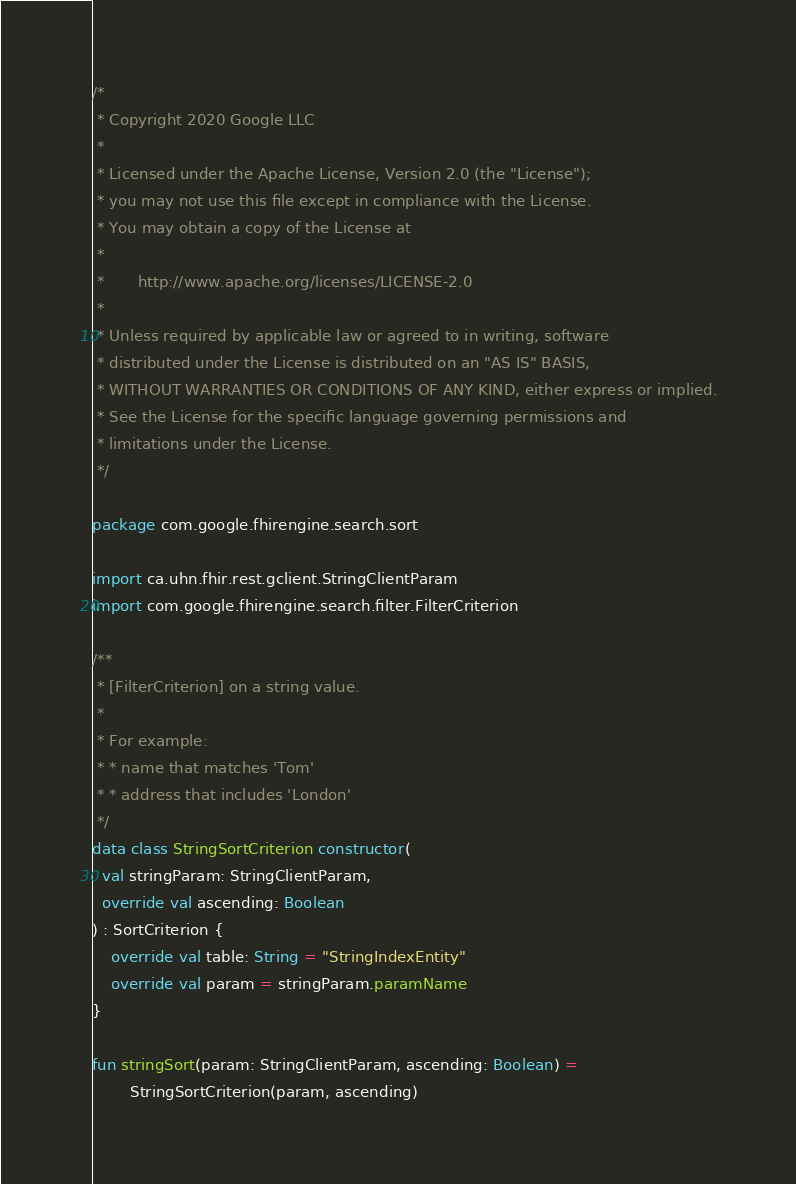<code> <loc_0><loc_0><loc_500><loc_500><_Kotlin_>/*
 * Copyright 2020 Google LLC
 *
 * Licensed under the Apache License, Version 2.0 (the "License");
 * you may not use this file except in compliance with the License.
 * You may obtain a copy of the License at
 *
 *       http://www.apache.org/licenses/LICENSE-2.0
 *
 * Unless required by applicable law or agreed to in writing, software
 * distributed under the License is distributed on an "AS IS" BASIS,
 * WITHOUT WARRANTIES OR CONDITIONS OF ANY KIND, either express or implied.
 * See the License for the specific language governing permissions and
 * limitations under the License.
 */

package com.google.fhirengine.search.sort

import ca.uhn.fhir.rest.gclient.StringClientParam
import com.google.fhirengine.search.filter.FilterCriterion

/**
 * [FilterCriterion] on a string value.
 *
 * For example:
 * * name that matches 'Tom'
 * * address that includes 'London'
 */
data class StringSortCriterion constructor(
  val stringParam: StringClientParam,
  override val ascending: Boolean
) : SortCriterion {
    override val table: String = "StringIndexEntity"
    override val param = stringParam.paramName
}

fun stringSort(param: StringClientParam, ascending: Boolean) =
        StringSortCriterion(param, ascending)
</code> 